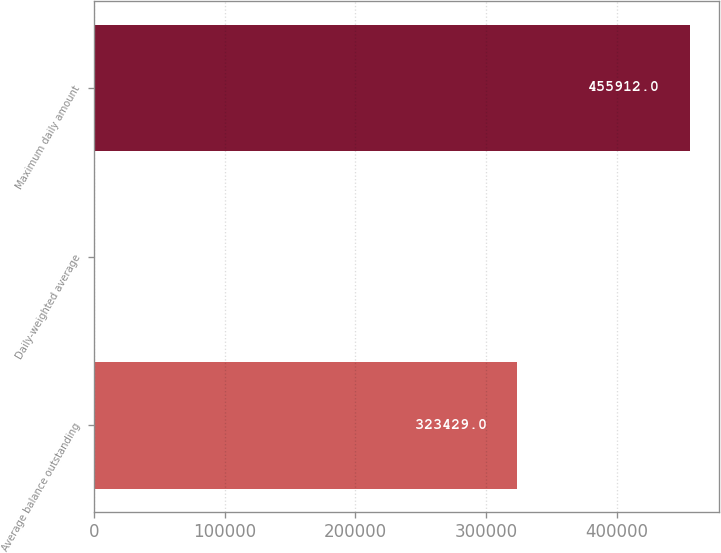Convert chart to OTSL. <chart><loc_0><loc_0><loc_500><loc_500><bar_chart><fcel>Average balance outstanding<fcel>Daily-weighted average<fcel>Maximum daily amount<nl><fcel>323429<fcel>1.3<fcel>455912<nl></chart> 